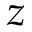<formula> <loc_0><loc_0><loc_500><loc_500>z</formula> 